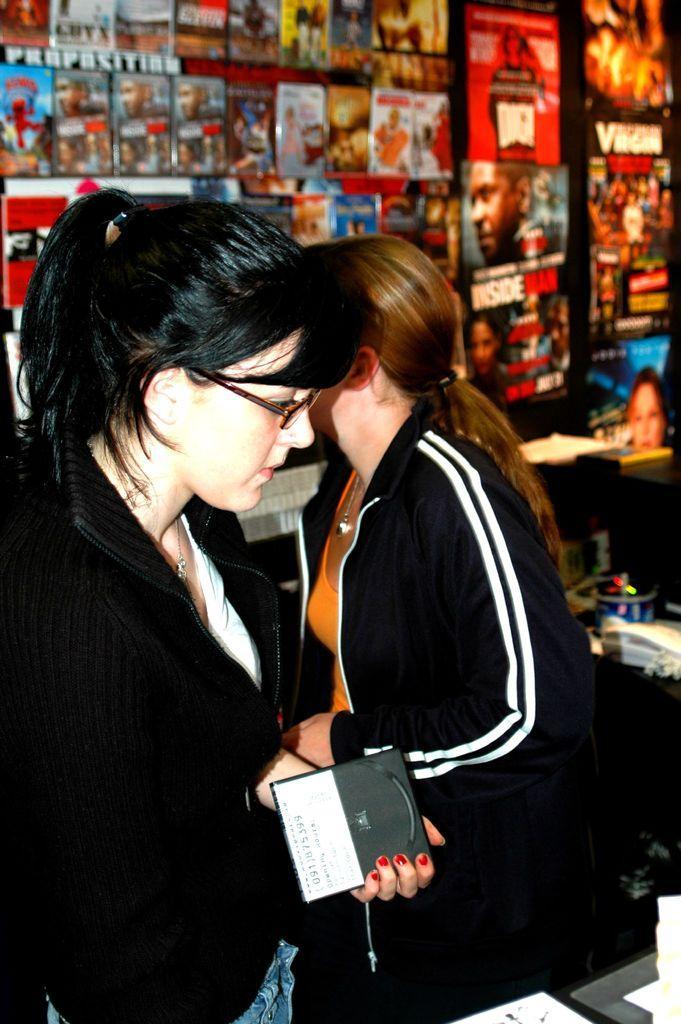In one or two sentences, can you explain what this image depicts? In this image I can see two women are standing in the front and I can see both of them are wearing black colour jackets. On the left side of this image I can see she is wearing specs and she is holding an object. In the background I can see number of posters and I can see this image is little bit blurry in the background. 